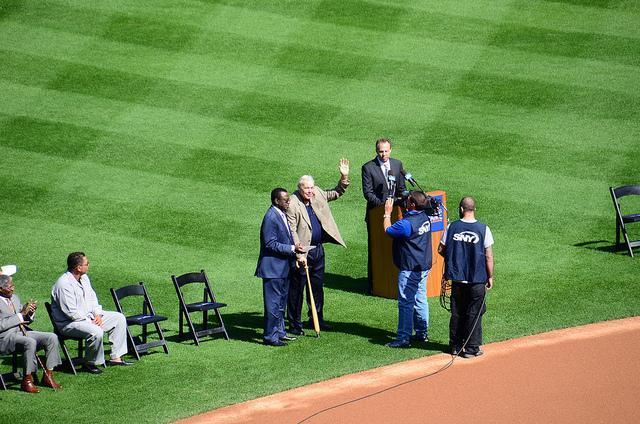How many empty chairs are there?
Give a very brief answer. 3. How many chairs are there?
Give a very brief answer. 2. How many people are there?
Give a very brief answer. 7. 